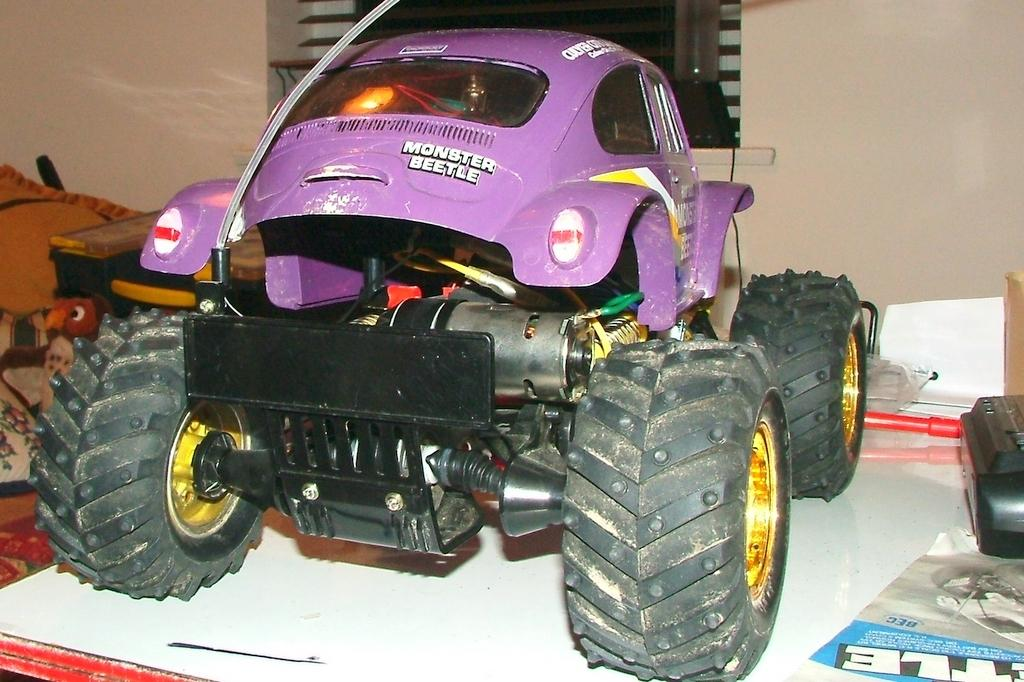What is the main subject in the foreground of the image? There is a vehicle on a table in the foreground of the image. What else can be seen on the table in the foreground? There are other items on the table in the foreground. What can be seen in the background of the image? There is a wall and a window in the background of the image. Where was the image taken? The image was taken in a room. What type of error can be seen on the vehicle in the image? There is no error visible on the vehicle in the image. How many family members are present in the image? There is no family present in the image; it features a vehicle on a table in a room. 